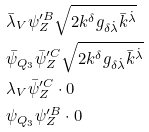Convert formula to latex. <formula><loc_0><loc_0><loc_500><loc_500>& \bar { \lambda } _ { V } \psi _ { Z } ^ { \prime B } \sqrt { 2 k ^ { \delta } g _ { \delta \dot { \lambda } } \bar { k } ^ { \dot { \lambda } } } \\ & \bar { \psi } _ { Q _ { 3 } } \bar { \psi } ^ { \prime C } _ { Z } \sqrt { 2 k ^ { \delta } g _ { \delta \dot { \lambda } } \bar { k } ^ { \dot { \lambda } } } \\ & \lambda _ { V } \bar { \psi } ^ { \prime C } _ { Z } \cdot 0 \\ & \psi _ { Q _ { 3 } } \psi ^ { \prime B } _ { Z } \cdot 0</formula> 